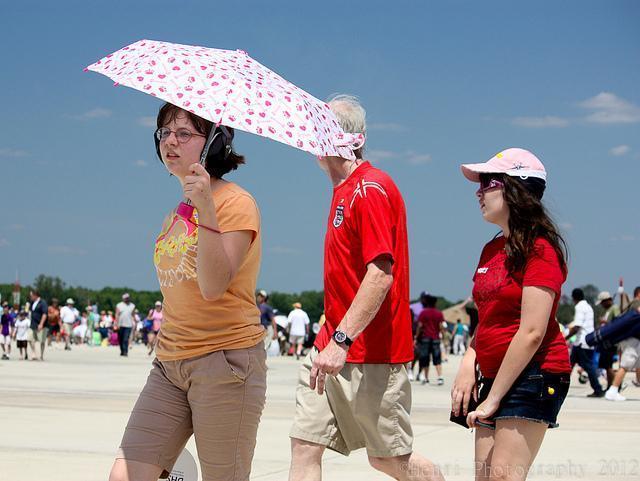How many people can be seen?
Give a very brief answer. 5. 